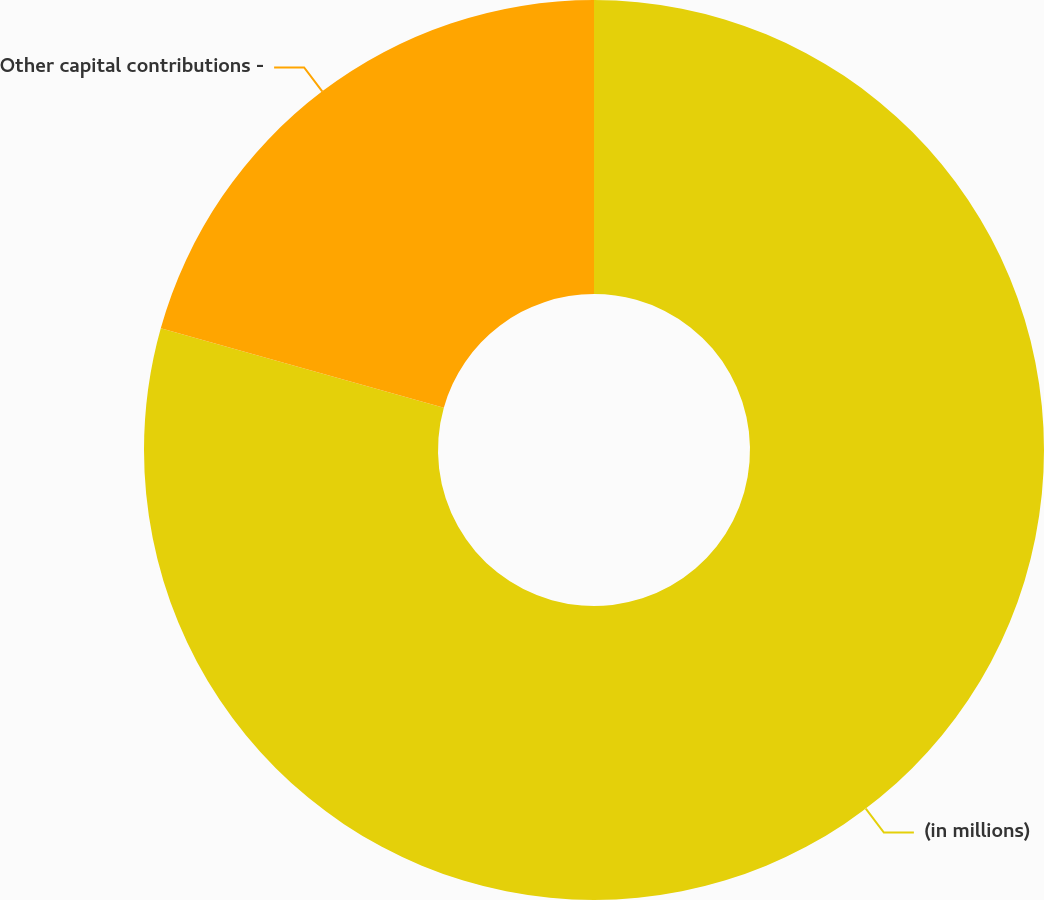Convert chart to OTSL. <chart><loc_0><loc_0><loc_500><loc_500><pie_chart><fcel>(in millions)<fcel>Other capital contributions -<nl><fcel>79.36%<fcel>20.64%<nl></chart> 